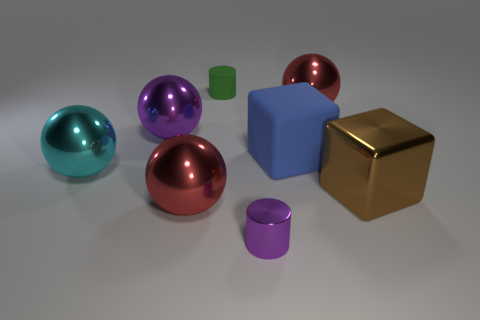Subtract all brown cylinders. Subtract all blue spheres. How many cylinders are left? 2 Add 2 big cubes. How many objects exist? 10 Subtract all blocks. How many objects are left? 6 Add 4 tiny brown matte cubes. How many tiny brown matte cubes exist? 4 Subtract 0 yellow cylinders. How many objects are left? 8 Subtract all large gray matte cylinders. Subtract all large brown metal objects. How many objects are left? 7 Add 6 metallic spheres. How many metallic spheres are left? 10 